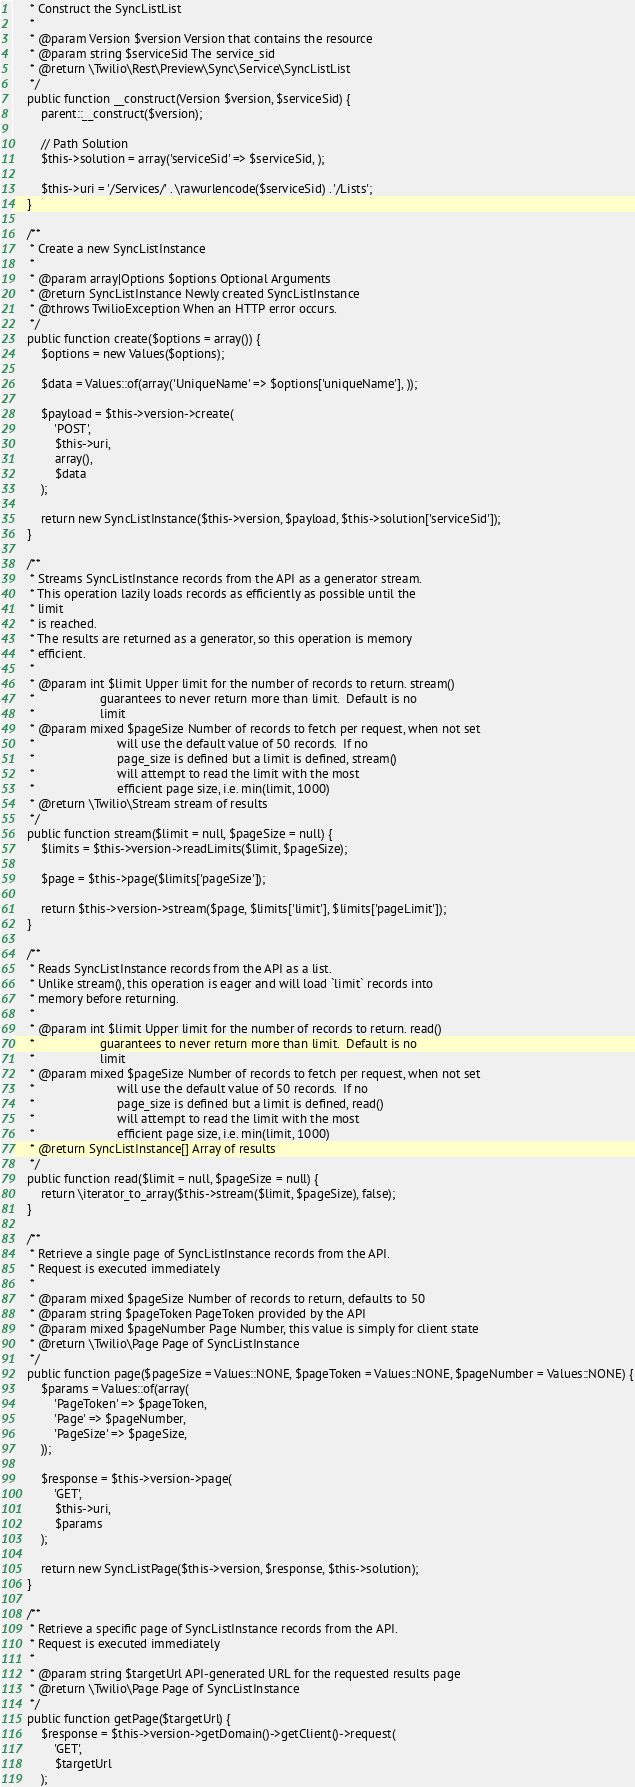<code> <loc_0><loc_0><loc_500><loc_500><_PHP_>     * Construct the SyncListList
     *
     * @param Version $version Version that contains the resource
     * @param string $serviceSid The service_sid
     * @return \Twilio\Rest\Preview\Sync\Service\SyncListList
     */
    public function __construct(Version $version, $serviceSid) {
        parent::__construct($version);

        // Path Solution
        $this->solution = array('serviceSid' => $serviceSid, );

        $this->uri = '/Services/' . \rawurlencode($serviceSid) . '/Lists';
    }

    /**
     * Create a new SyncListInstance
     *
     * @param array|Options $options Optional Arguments
     * @return SyncListInstance Newly created SyncListInstance
     * @throws TwilioException When an HTTP error occurs.
     */
    public function create($options = array()) {
        $options = new Values($options);

        $data = Values::of(array('UniqueName' => $options['uniqueName'], ));

        $payload = $this->version->create(
            'POST',
            $this->uri,
            array(),
            $data
        );

        return new SyncListInstance($this->version, $payload, $this->solution['serviceSid']);
    }

    /**
     * Streams SyncListInstance records from the API as a generator stream.
     * This operation lazily loads records as efficiently as possible until the
     * limit
     * is reached.
     * The results are returned as a generator, so this operation is memory
     * efficient.
     *
     * @param int $limit Upper limit for the number of records to return. stream()
     *                   guarantees to never return more than limit.  Default is no
     *                   limit
     * @param mixed $pageSize Number of records to fetch per request, when not set
     *                        will use the default value of 50 records.  If no
     *                        page_size is defined but a limit is defined, stream()
     *                        will attempt to read the limit with the most
     *                        efficient page size, i.e. min(limit, 1000)
     * @return \Twilio\Stream stream of results
     */
    public function stream($limit = null, $pageSize = null) {
        $limits = $this->version->readLimits($limit, $pageSize);

        $page = $this->page($limits['pageSize']);

        return $this->version->stream($page, $limits['limit'], $limits['pageLimit']);
    }

    /**
     * Reads SyncListInstance records from the API as a list.
     * Unlike stream(), this operation is eager and will load `limit` records into
     * memory before returning.
     *
     * @param int $limit Upper limit for the number of records to return. read()
     *                   guarantees to never return more than limit.  Default is no
     *                   limit
     * @param mixed $pageSize Number of records to fetch per request, when not set
     *                        will use the default value of 50 records.  If no
     *                        page_size is defined but a limit is defined, read()
     *                        will attempt to read the limit with the most
     *                        efficient page size, i.e. min(limit, 1000)
     * @return SyncListInstance[] Array of results
     */
    public function read($limit = null, $pageSize = null) {
        return \iterator_to_array($this->stream($limit, $pageSize), false);
    }

    /**
     * Retrieve a single page of SyncListInstance records from the API.
     * Request is executed immediately
     *
     * @param mixed $pageSize Number of records to return, defaults to 50
     * @param string $pageToken PageToken provided by the API
     * @param mixed $pageNumber Page Number, this value is simply for client state
     * @return \Twilio\Page Page of SyncListInstance
     */
    public function page($pageSize = Values::NONE, $pageToken = Values::NONE, $pageNumber = Values::NONE) {
        $params = Values::of(array(
            'PageToken' => $pageToken,
            'Page' => $pageNumber,
            'PageSize' => $pageSize,
        ));

        $response = $this->version->page(
            'GET',
            $this->uri,
            $params
        );

        return new SyncListPage($this->version, $response, $this->solution);
    }

    /**
     * Retrieve a specific page of SyncListInstance records from the API.
     * Request is executed immediately
     *
     * @param string $targetUrl API-generated URL for the requested results page
     * @return \Twilio\Page Page of SyncListInstance
     */
    public function getPage($targetUrl) {
        $response = $this->version->getDomain()->getClient()->request(
            'GET',
            $targetUrl
        );
</code> 